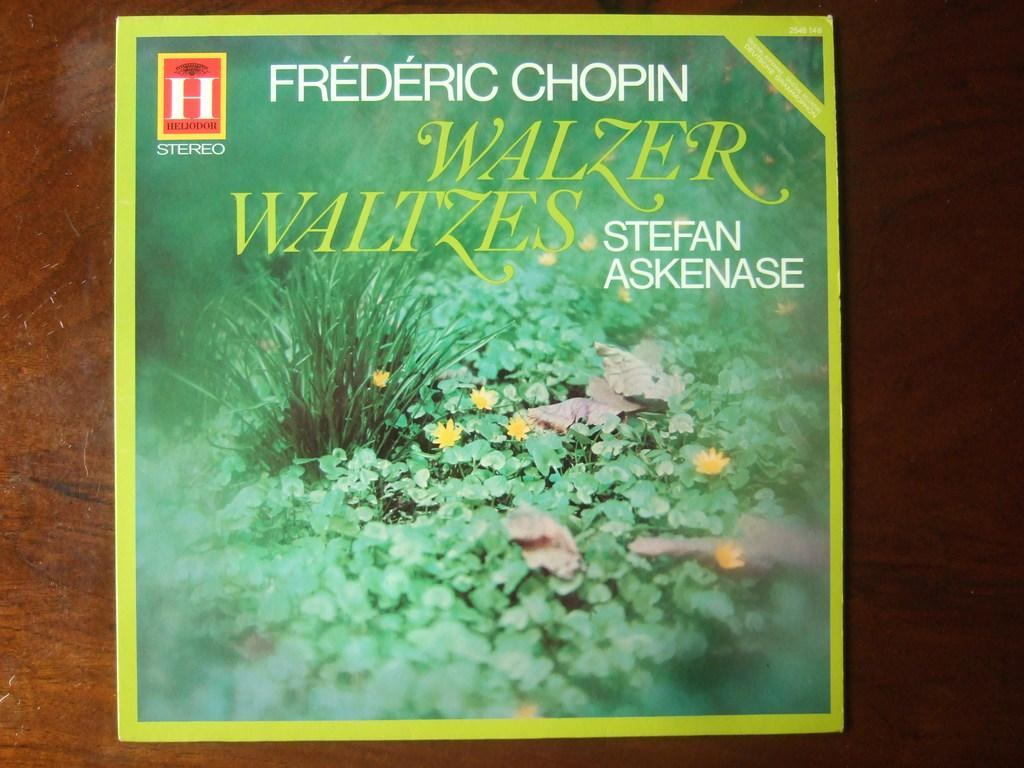What is present on the wooden surface in the image? There is a poster on the wooden surface. What can be found on the poster? There is text on the poster, as well as pictures of leaves, dry leaves, flowers, and grass. What type of surface is the poster placed on? The poster is placed on a wooden surface. What type of body is visible in the image? There is no body present in the image; it features a poster with text and pictures. Can you tell me the name of the father in the image? There is no father or any human figures present in the image; it features a poster with text and pictures. 